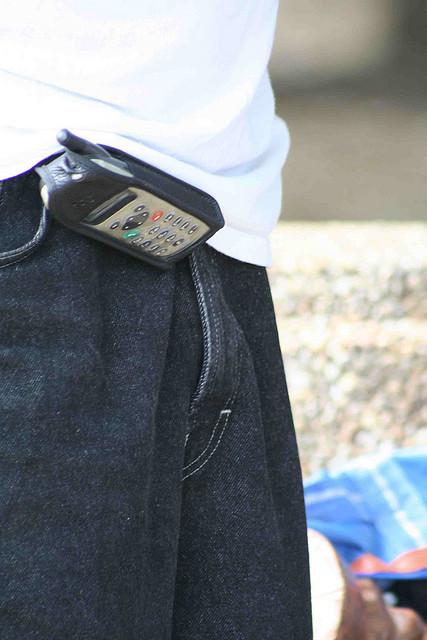What is on the person's belt?
Be succinct. Phone. Where is the phone?
Short answer required. Waist. Is the person wearing shorts?
Answer briefly. No. 